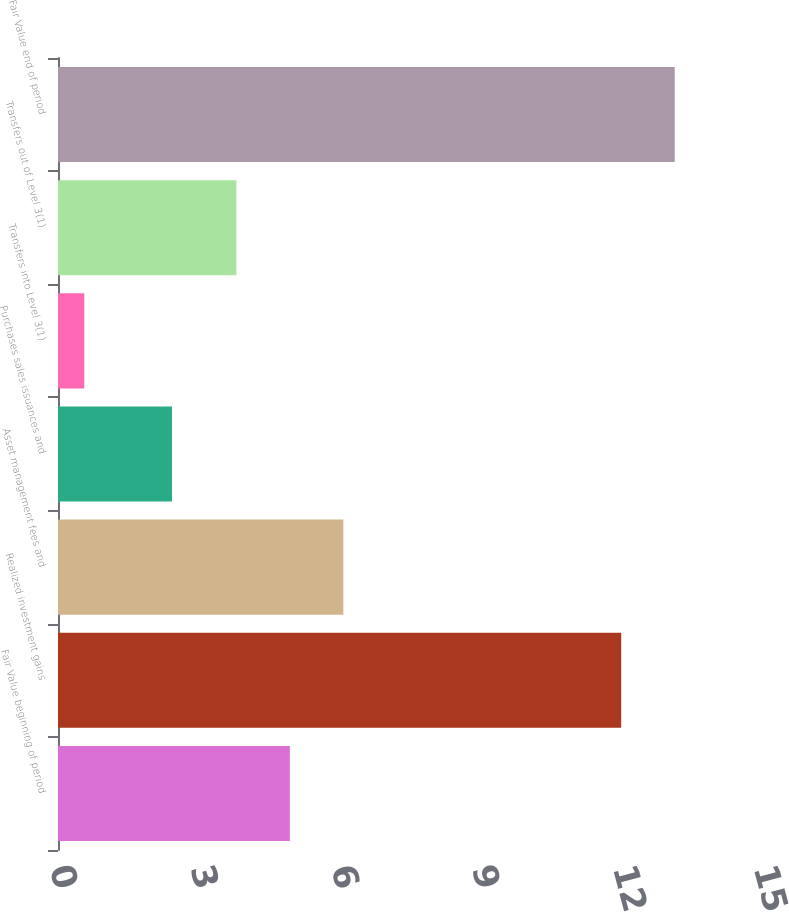Convert chart to OTSL. <chart><loc_0><loc_0><loc_500><loc_500><bar_chart><fcel>Fair Value beginning of period<fcel>Realized investment gains<fcel>Asset management fees and<fcel>Purchases sales issuances and<fcel>Transfers into Level 3(1)<fcel>Transfers out of Level 3(1)<fcel>Fair Value end of period<nl><fcel>4.94<fcel>12<fcel>6.08<fcel>2.43<fcel>0.56<fcel>3.8<fcel>13.14<nl></chart> 